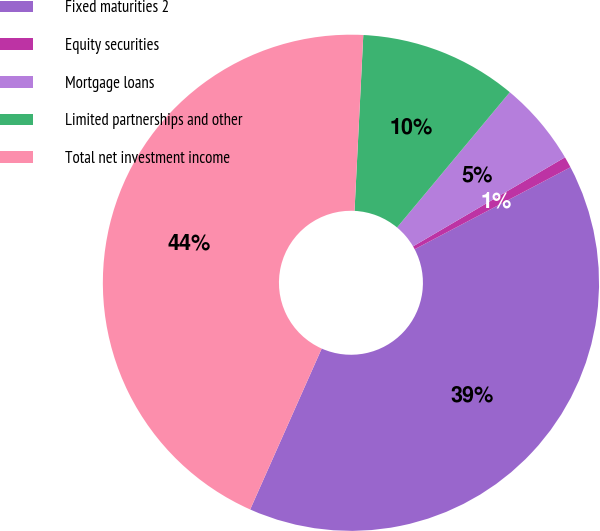Convert chart. <chart><loc_0><loc_0><loc_500><loc_500><pie_chart><fcel>Fixed maturities 2<fcel>Equity securities<fcel>Mortgage loans<fcel>Limited partnerships and other<fcel>Total net investment income<nl><fcel>39.37%<fcel>0.73%<fcel>5.5%<fcel>10.27%<fcel>44.14%<nl></chart> 